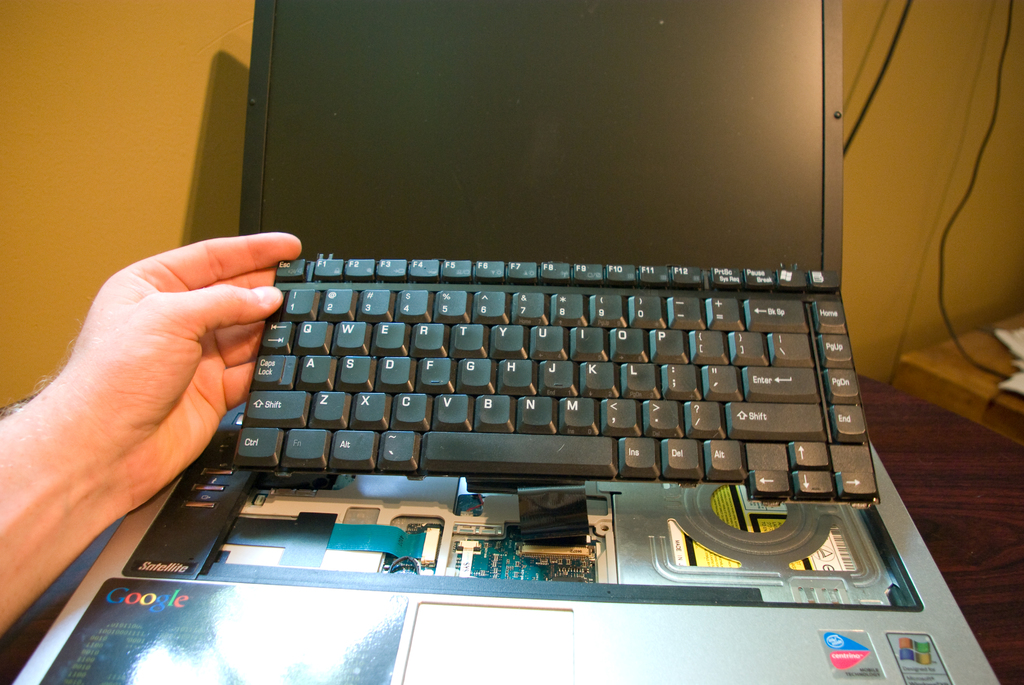What might have caused this laptop to be disassembled? The laptop could be disassembled for various reasons such as upgrading hardware components like RAM or SSD, repairing a malfunction, or simply for a technical examination. 